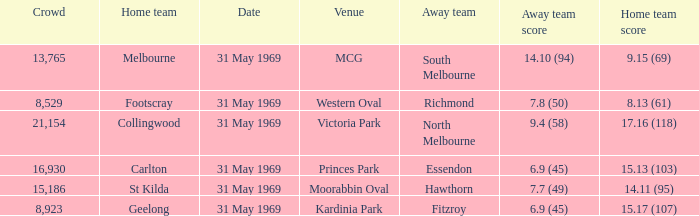Which domestic team tallied 1 St Kilda. 